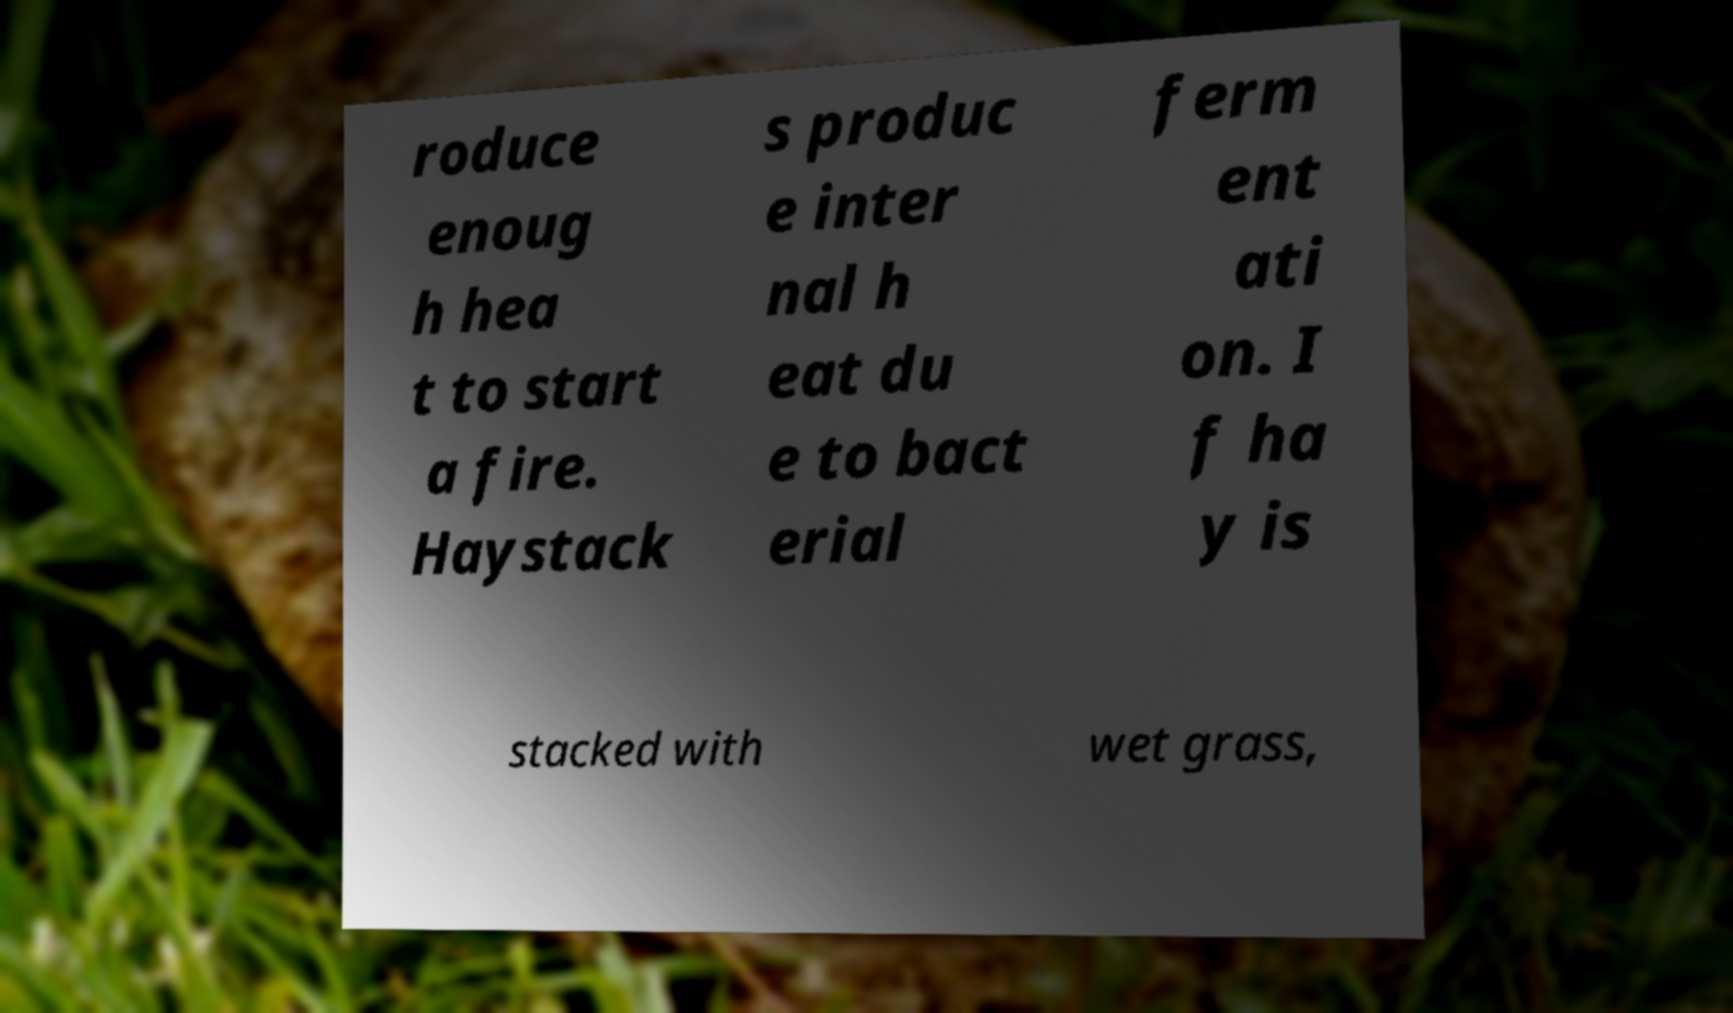Can you read and provide the text displayed in the image?This photo seems to have some interesting text. Can you extract and type it out for me? roduce enoug h hea t to start a fire. Haystack s produc e inter nal h eat du e to bact erial ferm ent ati on. I f ha y is stacked with wet grass, 